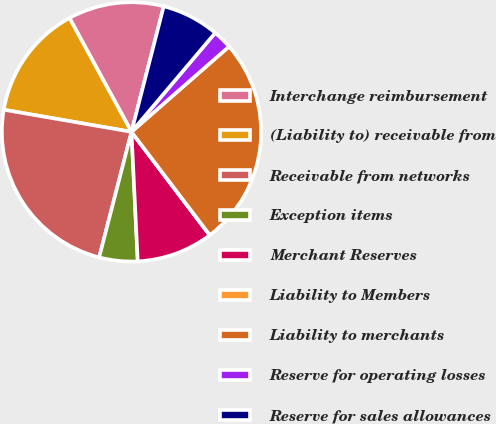Convert chart. <chart><loc_0><loc_0><loc_500><loc_500><pie_chart><fcel>Interchange reimbursement<fcel>(Liability to) receivable from<fcel>Receivable from networks<fcel>Exception items<fcel>Merchant Reserves<fcel>Liability to Members<fcel>Liability to merchants<fcel>Reserve for operating losses<fcel>Reserve for sales allowances<nl><fcel>11.94%<fcel>14.33%<fcel>23.72%<fcel>4.78%<fcel>9.55%<fcel>0.01%<fcel>26.11%<fcel>2.39%<fcel>7.17%<nl></chart> 